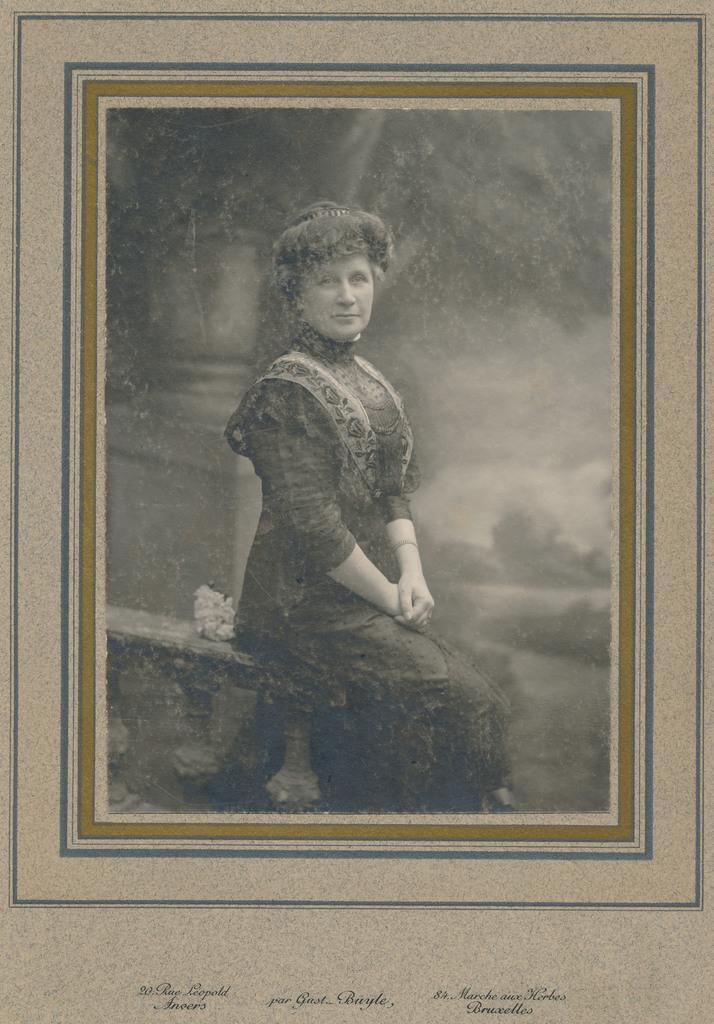How would you summarize this image in a sentence or two? This is a frame. On the frame a lady is sitting on something. At the bottom of the image something is written. 